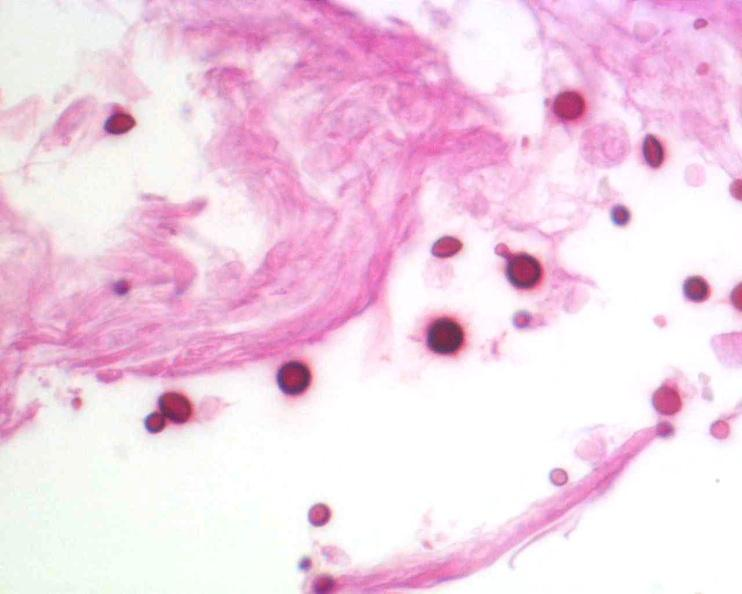s metastatic lung carcinoma present?
Answer the question using a single word or phrase. No 